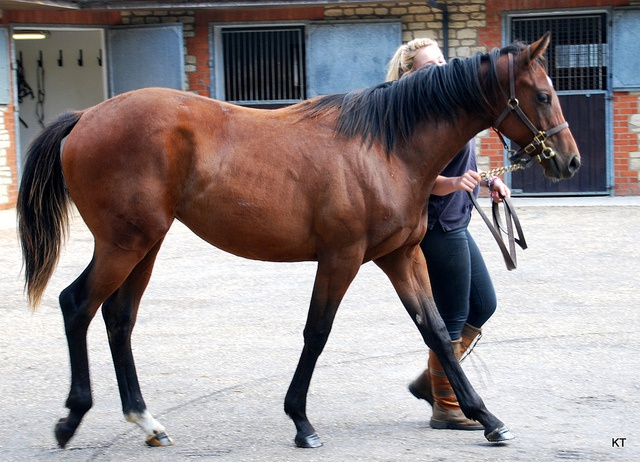Describe the objects in this image and their specific colors. I can see horse in gray, black, maroon, and brown tones and people in gray, black, white, and navy tones in this image. 